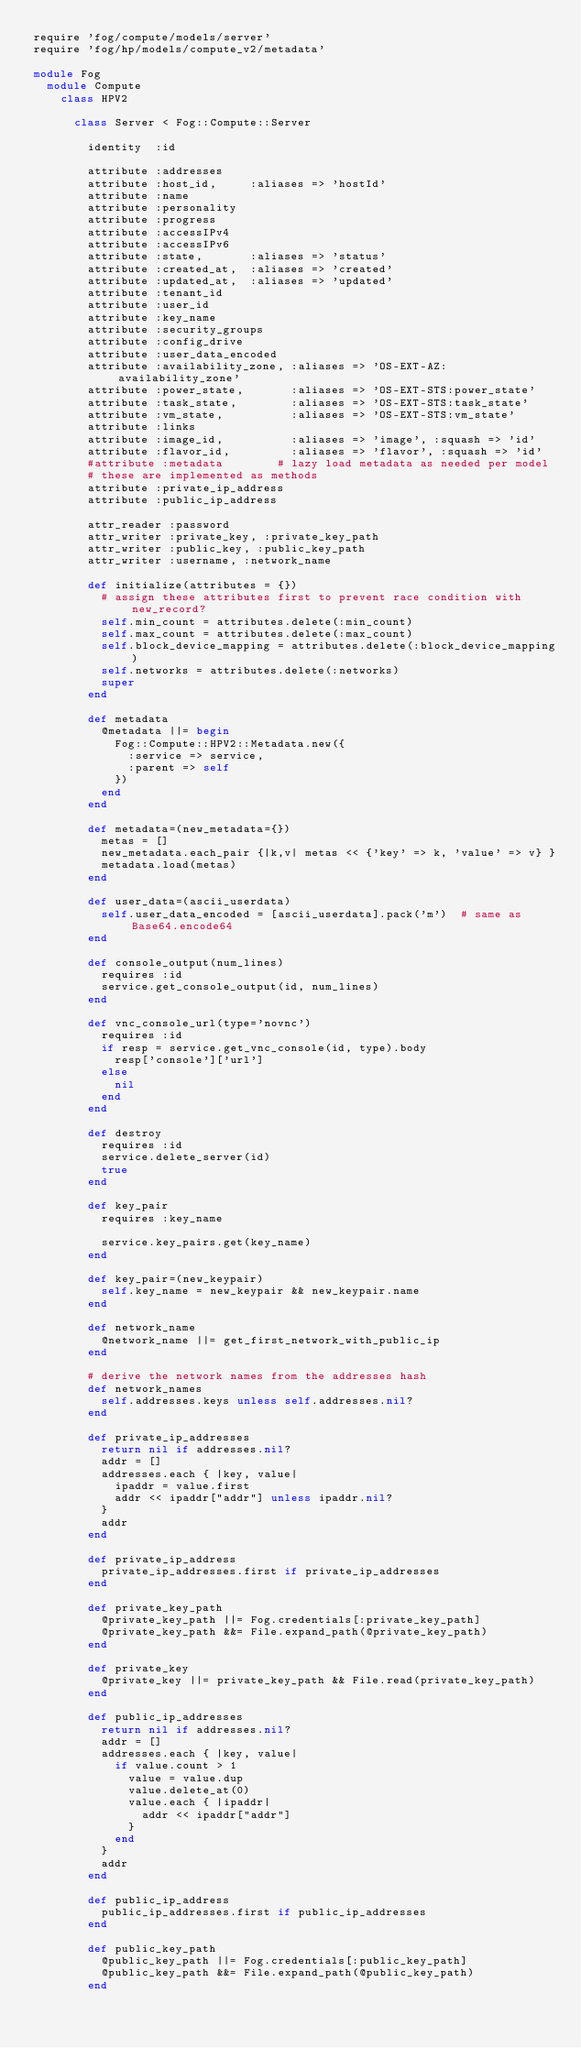Convert code to text. <code><loc_0><loc_0><loc_500><loc_500><_Ruby_>require 'fog/compute/models/server'
require 'fog/hp/models/compute_v2/metadata'

module Fog
  module Compute
    class HPV2

      class Server < Fog::Compute::Server

        identity  :id

        attribute :addresses
        attribute :host_id,     :aliases => 'hostId'
        attribute :name
        attribute :personality
        attribute :progress
        attribute :accessIPv4
        attribute :accessIPv6
        attribute :state,       :aliases => 'status'
        attribute :created_at,  :aliases => 'created'
        attribute :updated_at,  :aliases => 'updated'
        attribute :tenant_id
        attribute :user_id
        attribute :key_name
        attribute :security_groups
        attribute :config_drive
        attribute :user_data_encoded
        attribute :availability_zone, :aliases => 'OS-EXT-AZ:availability_zone'
        attribute :power_state,       :aliases => 'OS-EXT-STS:power_state'
        attribute :task_state,        :aliases => 'OS-EXT-STS:task_state'
        attribute :vm_state,          :aliases => 'OS-EXT-STS:vm_state'
        attribute :links
        attribute :image_id,          :aliases => 'image', :squash => 'id'
        attribute :flavor_id,         :aliases => 'flavor', :squash => 'id'
        #attribute :metadata        # lazy load metadata as needed per model
        # these are implemented as methods
        attribute :private_ip_address
        attribute :public_ip_address

        attr_reader :password
        attr_writer :private_key, :private_key_path
        attr_writer :public_key, :public_key_path
        attr_writer :username, :network_name

        def initialize(attributes = {})
          # assign these attributes first to prevent race condition with new_record?
          self.min_count = attributes.delete(:min_count)
          self.max_count = attributes.delete(:max_count)
          self.block_device_mapping = attributes.delete(:block_device_mapping)
          self.networks = attributes.delete(:networks)
          super
        end

        def metadata
          @metadata ||= begin
            Fog::Compute::HPV2::Metadata.new({
              :service => service,
              :parent => self
            })
          end
        end

        def metadata=(new_metadata={})
          metas = []
          new_metadata.each_pair {|k,v| metas << {'key' => k, 'value' => v} }
          metadata.load(metas)
        end

        def user_data=(ascii_userdata)
          self.user_data_encoded = [ascii_userdata].pack('m')  # same as Base64.encode64
        end

        def console_output(num_lines)
          requires :id
          service.get_console_output(id, num_lines)
        end

        def vnc_console_url(type='novnc')
          requires :id
          if resp = service.get_vnc_console(id, type).body
            resp['console']['url']
          else
            nil
          end
        end

        def destroy
          requires :id
          service.delete_server(id)
          true
        end

        def key_pair
          requires :key_name

          service.key_pairs.get(key_name)
        end

        def key_pair=(new_keypair)
          self.key_name = new_keypair && new_keypair.name
        end

        def network_name
          @network_name ||= get_first_network_with_public_ip
        end

        # derive the network names from the addresses hash
        def network_names
          self.addresses.keys unless self.addresses.nil?
        end

        def private_ip_addresses
          return nil if addresses.nil?
          addr = []
          addresses.each { |key, value|
            ipaddr = value.first
            addr << ipaddr["addr"] unless ipaddr.nil?
          }
          addr
        end

        def private_ip_address
          private_ip_addresses.first if private_ip_addresses
        end

        def private_key_path
          @private_key_path ||= Fog.credentials[:private_key_path]
          @private_key_path &&= File.expand_path(@private_key_path)
        end

        def private_key
          @private_key ||= private_key_path && File.read(private_key_path)
        end

        def public_ip_addresses
          return nil if addresses.nil?
          addr = []
          addresses.each { |key, value|
            if value.count > 1
              value = value.dup
              value.delete_at(0)
              value.each { |ipaddr|
                addr << ipaddr["addr"]
              }
            end
          }
          addr
        end

        def public_ip_address
          public_ip_addresses.first if public_ip_addresses
        end

        def public_key_path
          @public_key_path ||= Fog.credentials[:public_key_path]
          @public_key_path &&= File.expand_path(@public_key_path)
        end
</code> 